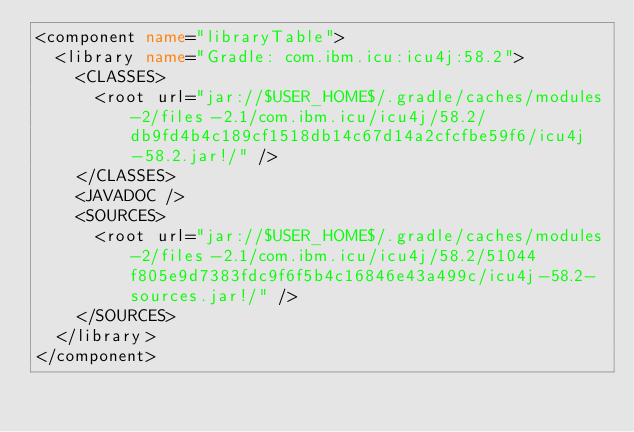Convert code to text. <code><loc_0><loc_0><loc_500><loc_500><_XML_><component name="libraryTable">
  <library name="Gradle: com.ibm.icu:icu4j:58.2">
    <CLASSES>
      <root url="jar://$USER_HOME$/.gradle/caches/modules-2/files-2.1/com.ibm.icu/icu4j/58.2/db9fd4b4c189cf1518db14c67d14a2cfcfbe59f6/icu4j-58.2.jar!/" />
    </CLASSES>
    <JAVADOC />
    <SOURCES>
      <root url="jar://$USER_HOME$/.gradle/caches/modules-2/files-2.1/com.ibm.icu/icu4j/58.2/51044f805e9d7383fdc9f6f5b4c16846e43a499c/icu4j-58.2-sources.jar!/" />
    </SOURCES>
  </library>
</component></code> 